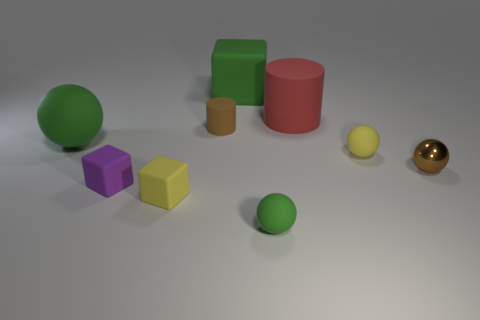Subtract 1 balls. How many balls are left? 3 Add 1 red rubber things. How many objects exist? 10 Subtract all spheres. How many objects are left? 5 Add 6 large green metal cylinders. How many large green metal cylinders exist? 6 Subtract 0 gray balls. How many objects are left? 9 Subtract all tiny cylinders. Subtract all brown objects. How many objects are left? 6 Add 7 green rubber blocks. How many green rubber blocks are left? 8 